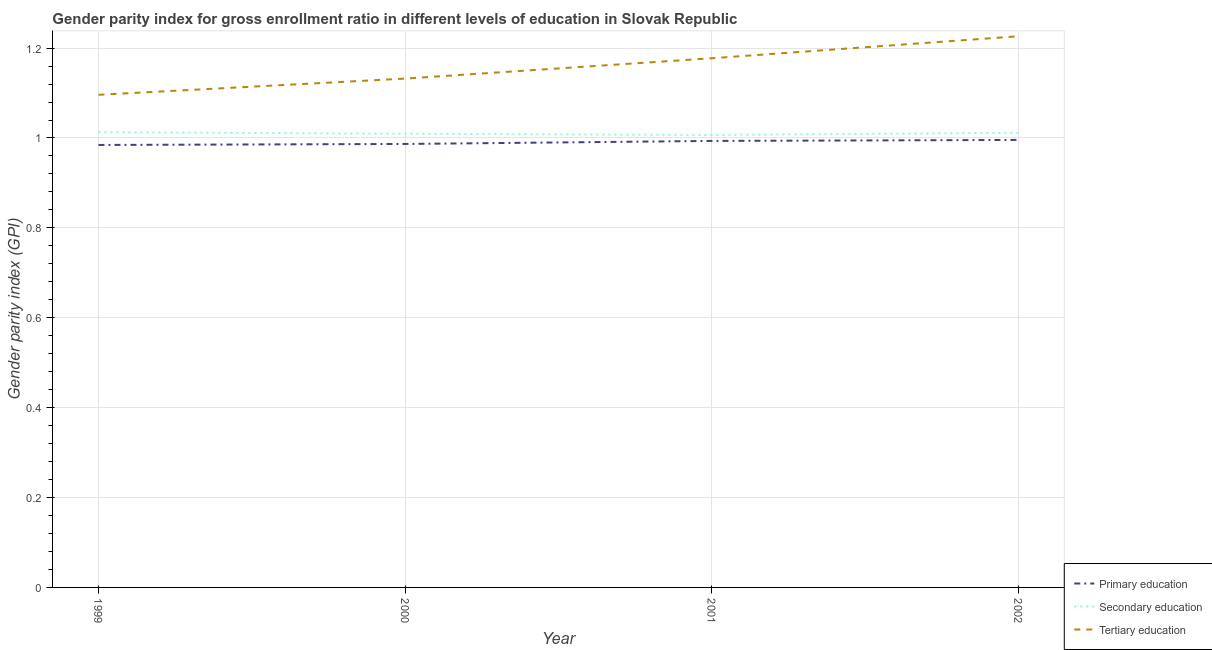Does the line corresponding to gender parity index in primary education intersect with the line corresponding to gender parity index in tertiary education?
Your response must be concise. No. What is the gender parity index in secondary education in 2002?
Offer a terse response. 1.01. Across all years, what is the maximum gender parity index in primary education?
Give a very brief answer. 1. Across all years, what is the minimum gender parity index in secondary education?
Your response must be concise. 1.01. In which year was the gender parity index in tertiary education maximum?
Offer a very short reply. 2002. In which year was the gender parity index in secondary education minimum?
Ensure brevity in your answer.  2001. What is the total gender parity index in primary education in the graph?
Give a very brief answer. 3.96. What is the difference between the gender parity index in secondary education in 2000 and that in 2001?
Give a very brief answer. 0. What is the difference between the gender parity index in tertiary education in 1999 and the gender parity index in secondary education in 2000?
Your response must be concise. 0.09. What is the average gender parity index in tertiary education per year?
Give a very brief answer. 1.16. In the year 2001, what is the difference between the gender parity index in tertiary education and gender parity index in primary education?
Offer a terse response. 0.18. In how many years, is the gender parity index in tertiary education greater than 0.4?
Offer a very short reply. 4. What is the ratio of the gender parity index in tertiary education in 1999 to that in 2000?
Give a very brief answer. 0.97. Is the gender parity index in tertiary education in 1999 less than that in 2002?
Ensure brevity in your answer.  Yes. What is the difference between the highest and the second highest gender parity index in primary education?
Give a very brief answer. 0. What is the difference between the highest and the lowest gender parity index in secondary education?
Provide a short and direct response. 0.01. Is the sum of the gender parity index in secondary education in 2000 and 2001 greater than the maximum gender parity index in primary education across all years?
Your answer should be very brief. Yes. Does the gender parity index in primary education monotonically increase over the years?
Your answer should be very brief. Yes. How many years are there in the graph?
Your response must be concise. 4. What is the difference between two consecutive major ticks on the Y-axis?
Provide a short and direct response. 0.2. Are the values on the major ticks of Y-axis written in scientific E-notation?
Your answer should be very brief. No. Where does the legend appear in the graph?
Your response must be concise. Bottom right. What is the title of the graph?
Make the answer very short. Gender parity index for gross enrollment ratio in different levels of education in Slovak Republic. Does "Domestic" appear as one of the legend labels in the graph?
Your answer should be compact. No. What is the label or title of the Y-axis?
Your answer should be very brief. Gender parity index (GPI). What is the Gender parity index (GPI) of Primary education in 1999?
Give a very brief answer. 0.98. What is the Gender parity index (GPI) in Secondary education in 1999?
Your answer should be very brief. 1.01. What is the Gender parity index (GPI) in Tertiary education in 1999?
Offer a terse response. 1.1. What is the Gender parity index (GPI) in Primary education in 2000?
Ensure brevity in your answer.  0.99. What is the Gender parity index (GPI) in Secondary education in 2000?
Your response must be concise. 1.01. What is the Gender parity index (GPI) in Tertiary education in 2000?
Your response must be concise. 1.13. What is the Gender parity index (GPI) of Primary education in 2001?
Your answer should be compact. 0.99. What is the Gender parity index (GPI) of Secondary education in 2001?
Your answer should be compact. 1.01. What is the Gender parity index (GPI) in Tertiary education in 2001?
Provide a short and direct response. 1.18. What is the Gender parity index (GPI) of Primary education in 2002?
Ensure brevity in your answer.  1. What is the Gender parity index (GPI) in Secondary education in 2002?
Offer a terse response. 1.01. What is the Gender parity index (GPI) in Tertiary education in 2002?
Provide a short and direct response. 1.23. Across all years, what is the maximum Gender parity index (GPI) of Primary education?
Give a very brief answer. 1. Across all years, what is the maximum Gender parity index (GPI) of Secondary education?
Keep it short and to the point. 1.01. Across all years, what is the maximum Gender parity index (GPI) of Tertiary education?
Keep it short and to the point. 1.23. Across all years, what is the minimum Gender parity index (GPI) of Primary education?
Keep it short and to the point. 0.98. Across all years, what is the minimum Gender parity index (GPI) of Secondary education?
Your answer should be very brief. 1.01. Across all years, what is the minimum Gender parity index (GPI) of Tertiary education?
Your response must be concise. 1.1. What is the total Gender parity index (GPI) in Primary education in the graph?
Ensure brevity in your answer.  3.96. What is the total Gender parity index (GPI) in Secondary education in the graph?
Your response must be concise. 4.04. What is the total Gender parity index (GPI) of Tertiary education in the graph?
Provide a succinct answer. 4.63. What is the difference between the Gender parity index (GPI) in Primary education in 1999 and that in 2000?
Offer a very short reply. -0. What is the difference between the Gender parity index (GPI) in Secondary education in 1999 and that in 2000?
Your answer should be compact. 0. What is the difference between the Gender parity index (GPI) in Tertiary education in 1999 and that in 2000?
Offer a terse response. -0.04. What is the difference between the Gender parity index (GPI) in Primary education in 1999 and that in 2001?
Make the answer very short. -0.01. What is the difference between the Gender parity index (GPI) of Secondary education in 1999 and that in 2001?
Provide a short and direct response. 0.01. What is the difference between the Gender parity index (GPI) in Tertiary education in 1999 and that in 2001?
Ensure brevity in your answer.  -0.08. What is the difference between the Gender parity index (GPI) of Primary education in 1999 and that in 2002?
Keep it short and to the point. -0.01. What is the difference between the Gender parity index (GPI) in Secondary education in 1999 and that in 2002?
Make the answer very short. 0. What is the difference between the Gender parity index (GPI) in Tertiary education in 1999 and that in 2002?
Provide a short and direct response. -0.13. What is the difference between the Gender parity index (GPI) of Primary education in 2000 and that in 2001?
Keep it short and to the point. -0.01. What is the difference between the Gender parity index (GPI) in Secondary education in 2000 and that in 2001?
Offer a very short reply. 0. What is the difference between the Gender parity index (GPI) of Tertiary education in 2000 and that in 2001?
Your response must be concise. -0.05. What is the difference between the Gender parity index (GPI) of Primary education in 2000 and that in 2002?
Your response must be concise. -0.01. What is the difference between the Gender parity index (GPI) in Secondary education in 2000 and that in 2002?
Offer a terse response. -0. What is the difference between the Gender parity index (GPI) in Tertiary education in 2000 and that in 2002?
Your answer should be very brief. -0.09. What is the difference between the Gender parity index (GPI) in Primary education in 2001 and that in 2002?
Your response must be concise. -0. What is the difference between the Gender parity index (GPI) of Secondary education in 2001 and that in 2002?
Give a very brief answer. -0. What is the difference between the Gender parity index (GPI) in Tertiary education in 2001 and that in 2002?
Offer a terse response. -0.05. What is the difference between the Gender parity index (GPI) of Primary education in 1999 and the Gender parity index (GPI) of Secondary education in 2000?
Provide a succinct answer. -0.02. What is the difference between the Gender parity index (GPI) in Primary education in 1999 and the Gender parity index (GPI) in Tertiary education in 2000?
Offer a terse response. -0.15. What is the difference between the Gender parity index (GPI) of Secondary education in 1999 and the Gender parity index (GPI) of Tertiary education in 2000?
Keep it short and to the point. -0.12. What is the difference between the Gender parity index (GPI) of Primary education in 1999 and the Gender parity index (GPI) of Secondary education in 2001?
Provide a short and direct response. -0.02. What is the difference between the Gender parity index (GPI) of Primary education in 1999 and the Gender parity index (GPI) of Tertiary education in 2001?
Give a very brief answer. -0.19. What is the difference between the Gender parity index (GPI) in Secondary education in 1999 and the Gender parity index (GPI) in Tertiary education in 2001?
Offer a very short reply. -0.16. What is the difference between the Gender parity index (GPI) in Primary education in 1999 and the Gender parity index (GPI) in Secondary education in 2002?
Offer a terse response. -0.03. What is the difference between the Gender parity index (GPI) of Primary education in 1999 and the Gender parity index (GPI) of Tertiary education in 2002?
Your answer should be very brief. -0.24. What is the difference between the Gender parity index (GPI) in Secondary education in 1999 and the Gender parity index (GPI) in Tertiary education in 2002?
Provide a short and direct response. -0.21. What is the difference between the Gender parity index (GPI) of Primary education in 2000 and the Gender parity index (GPI) of Secondary education in 2001?
Your answer should be very brief. -0.02. What is the difference between the Gender parity index (GPI) of Primary education in 2000 and the Gender parity index (GPI) of Tertiary education in 2001?
Your answer should be compact. -0.19. What is the difference between the Gender parity index (GPI) of Secondary education in 2000 and the Gender parity index (GPI) of Tertiary education in 2001?
Your answer should be very brief. -0.17. What is the difference between the Gender parity index (GPI) of Primary education in 2000 and the Gender parity index (GPI) of Secondary education in 2002?
Provide a short and direct response. -0.02. What is the difference between the Gender parity index (GPI) of Primary education in 2000 and the Gender parity index (GPI) of Tertiary education in 2002?
Your answer should be compact. -0.24. What is the difference between the Gender parity index (GPI) of Secondary education in 2000 and the Gender parity index (GPI) of Tertiary education in 2002?
Offer a terse response. -0.22. What is the difference between the Gender parity index (GPI) of Primary education in 2001 and the Gender parity index (GPI) of Secondary education in 2002?
Keep it short and to the point. -0.02. What is the difference between the Gender parity index (GPI) of Primary education in 2001 and the Gender parity index (GPI) of Tertiary education in 2002?
Keep it short and to the point. -0.23. What is the difference between the Gender parity index (GPI) in Secondary education in 2001 and the Gender parity index (GPI) in Tertiary education in 2002?
Offer a terse response. -0.22. What is the average Gender parity index (GPI) of Secondary education per year?
Your answer should be very brief. 1.01. What is the average Gender parity index (GPI) in Tertiary education per year?
Offer a very short reply. 1.16. In the year 1999, what is the difference between the Gender parity index (GPI) in Primary education and Gender parity index (GPI) in Secondary education?
Provide a succinct answer. -0.03. In the year 1999, what is the difference between the Gender parity index (GPI) in Primary education and Gender parity index (GPI) in Tertiary education?
Offer a very short reply. -0.11. In the year 1999, what is the difference between the Gender parity index (GPI) of Secondary education and Gender parity index (GPI) of Tertiary education?
Offer a terse response. -0.08. In the year 2000, what is the difference between the Gender parity index (GPI) of Primary education and Gender parity index (GPI) of Secondary education?
Offer a very short reply. -0.02. In the year 2000, what is the difference between the Gender parity index (GPI) in Primary education and Gender parity index (GPI) in Tertiary education?
Your answer should be very brief. -0.15. In the year 2000, what is the difference between the Gender parity index (GPI) of Secondary education and Gender parity index (GPI) of Tertiary education?
Ensure brevity in your answer.  -0.12. In the year 2001, what is the difference between the Gender parity index (GPI) of Primary education and Gender parity index (GPI) of Secondary education?
Keep it short and to the point. -0.01. In the year 2001, what is the difference between the Gender parity index (GPI) of Primary education and Gender parity index (GPI) of Tertiary education?
Make the answer very short. -0.18. In the year 2001, what is the difference between the Gender parity index (GPI) of Secondary education and Gender parity index (GPI) of Tertiary education?
Offer a terse response. -0.17. In the year 2002, what is the difference between the Gender parity index (GPI) in Primary education and Gender parity index (GPI) in Secondary education?
Your answer should be very brief. -0.02. In the year 2002, what is the difference between the Gender parity index (GPI) of Primary education and Gender parity index (GPI) of Tertiary education?
Your response must be concise. -0.23. In the year 2002, what is the difference between the Gender parity index (GPI) of Secondary education and Gender parity index (GPI) of Tertiary education?
Keep it short and to the point. -0.21. What is the ratio of the Gender parity index (GPI) of Tertiary education in 1999 to that in 2000?
Make the answer very short. 0.97. What is the ratio of the Gender parity index (GPI) of Primary education in 1999 to that in 2001?
Your response must be concise. 0.99. What is the ratio of the Gender parity index (GPI) in Secondary education in 1999 to that in 2001?
Provide a succinct answer. 1.01. What is the ratio of the Gender parity index (GPI) of Tertiary education in 1999 to that in 2001?
Provide a succinct answer. 0.93. What is the ratio of the Gender parity index (GPI) of Tertiary education in 1999 to that in 2002?
Offer a very short reply. 0.89. What is the ratio of the Gender parity index (GPI) in Secondary education in 2000 to that in 2001?
Your answer should be compact. 1. What is the ratio of the Gender parity index (GPI) in Tertiary education in 2000 to that in 2001?
Offer a very short reply. 0.96. What is the ratio of the Gender parity index (GPI) of Primary education in 2000 to that in 2002?
Provide a short and direct response. 0.99. What is the ratio of the Gender parity index (GPI) in Tertiary education in 2000 to that in 2002?
Make the answer very short. 0.92. What is the ratio of the Gender parity index (GPI) in Tertiary education in 2001 to that in 2002?
Your answer should be very brief. 0.96. What is the difference between the highest and the second highest Gender parity index (GPI) in Primary education?
Keep it short and to the point. 0. What is the difference between the highest and the second highest Gender parity index (GPI) of Secondary education?
Your answer should be compact. 0. What is the difference between the highest and the second highest Gender parity index (GPI) in Tertiary education?
Your response must be concise. 0.05. What is the difference between the highest and the lowest Gender parity index (GPI) in Primary education?
Your answer should be very brief. 0.01. What is the difference between the highest and the lowest Gender parity index (GPI) of Secondary education?
Ensure brevity in your answer.  0.01. What is the difference between the highest and the lowest Gender parity index (GPI) in Tertiary education?
Ensure brevity in your answer.  0.13. 